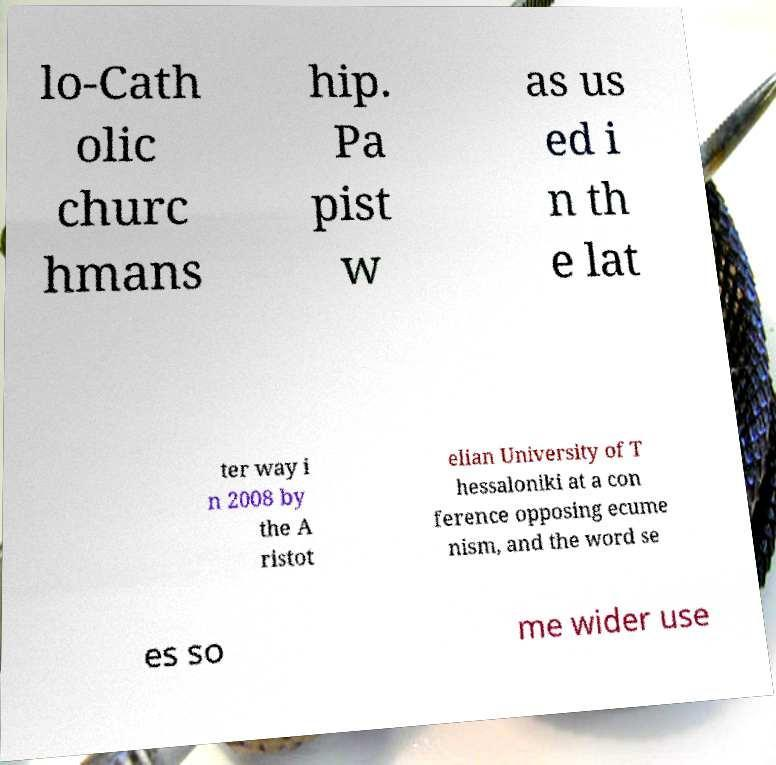Could you assist in decoding the text presented in this image and type it out clearly? lo-Cath olic churc hmans hip. Pa pist w as us ed i n th e lat ter way i n 2008 by the A ristot elian University of T hessaloniki at a con ference opposing ecume nism, and the word se es so me wider use 